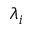<formula> <loc_0><loc_0><loc_500><loc_500>\lambda _ { i }</formula> 